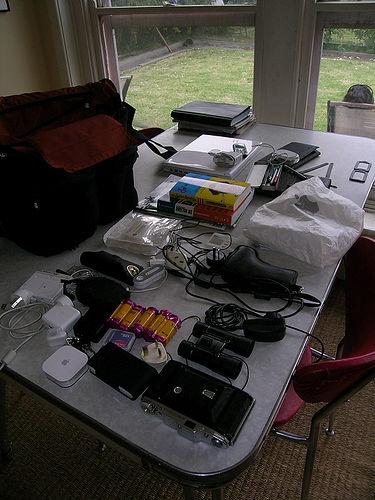Where are the books located?
Concise answer only. Table. What did she pack?
Write a very short answer. Electronics. Is the laptop on?
Quick response, please. No. Is this an art project?
Write a very short answer. No. How many electronics are pictured?
Give a very brief answer. 8. Is this a breakfast table?
Concise answer only. No. Where is the game controller?
Be succinct. On table. How many glasses are on the table?
Concise answer only. 0. Is the keyboard pictured?
Short answer required. No. Is the phone a current model?
Keep it brief. No. What color is the table?
Keep it brief. White. Are those elevators in the back?
Concise answer only. No. What color is the chair?
Give a very brief answer. Red. Is the window transparent?
Be succinct. Yes. Is it a sunny day?
Short answer required. Yes. 